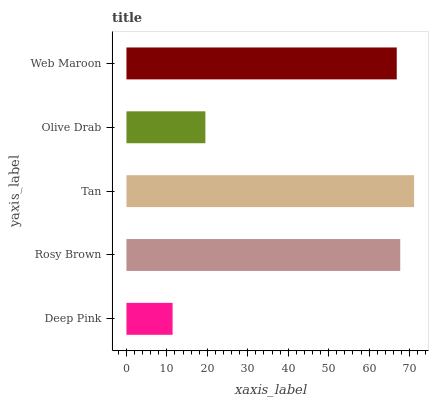Is Deep Pink the minimum?
Answer yes or no. Yes. Is Tan the maximum?
Answer yes or no. Yes. Is Rosy Brown the minimum?
Answer yes or no. No. Is Rosy Brown the maximum?
Answer yes or no. No. Is Rosy Brown greater than Deep Pink?
Answer yes or no. Yes. Is Deep Pink less than Rosy Brown?
Answer yes or no. Yes. Is Deep Pink greater than Rosy Brown?
Answer yes or no. No. Is Rosy Brown less than Deep Pink?
Answer yes or no. No. Is Web Maroon the high median?
Answer yes or no. Yes. Is Web Maroon the low median?
Answer yes or no. Yes. Is Tan the high median?
Answer yes or no. No. Is Rosy Brown the low median?
Answer yes or no. No. 